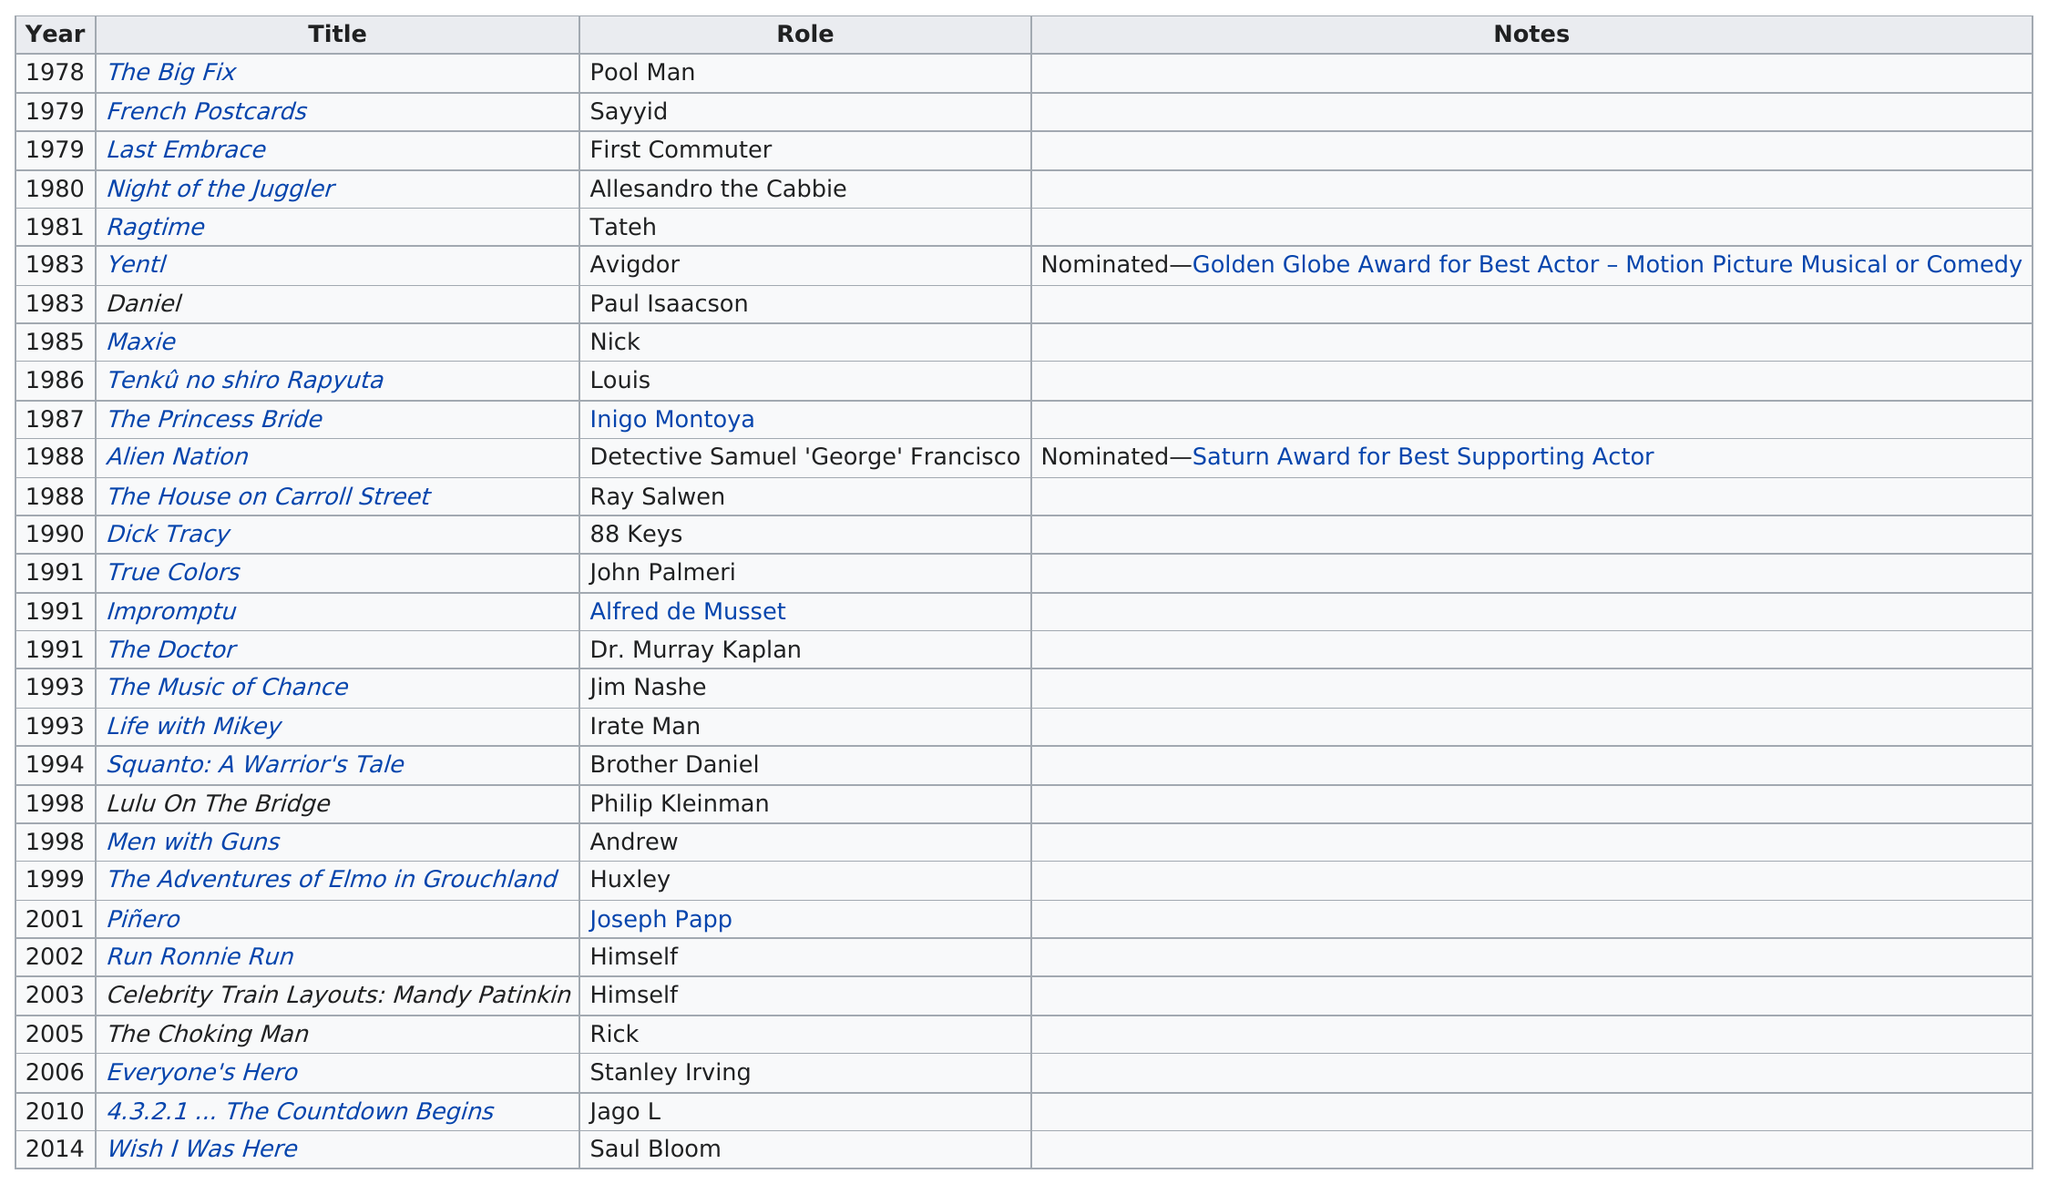Point out several critical features in this image. Mandy Patinkin was nominated for the Saturn Award for Best Supporting Actor in 1988. In 1991, Mandy Patinkin played three film roles. In 1998, Mandy Patinkin starred in two films: "Lulu on the Bridge" and "Men with Guns. 